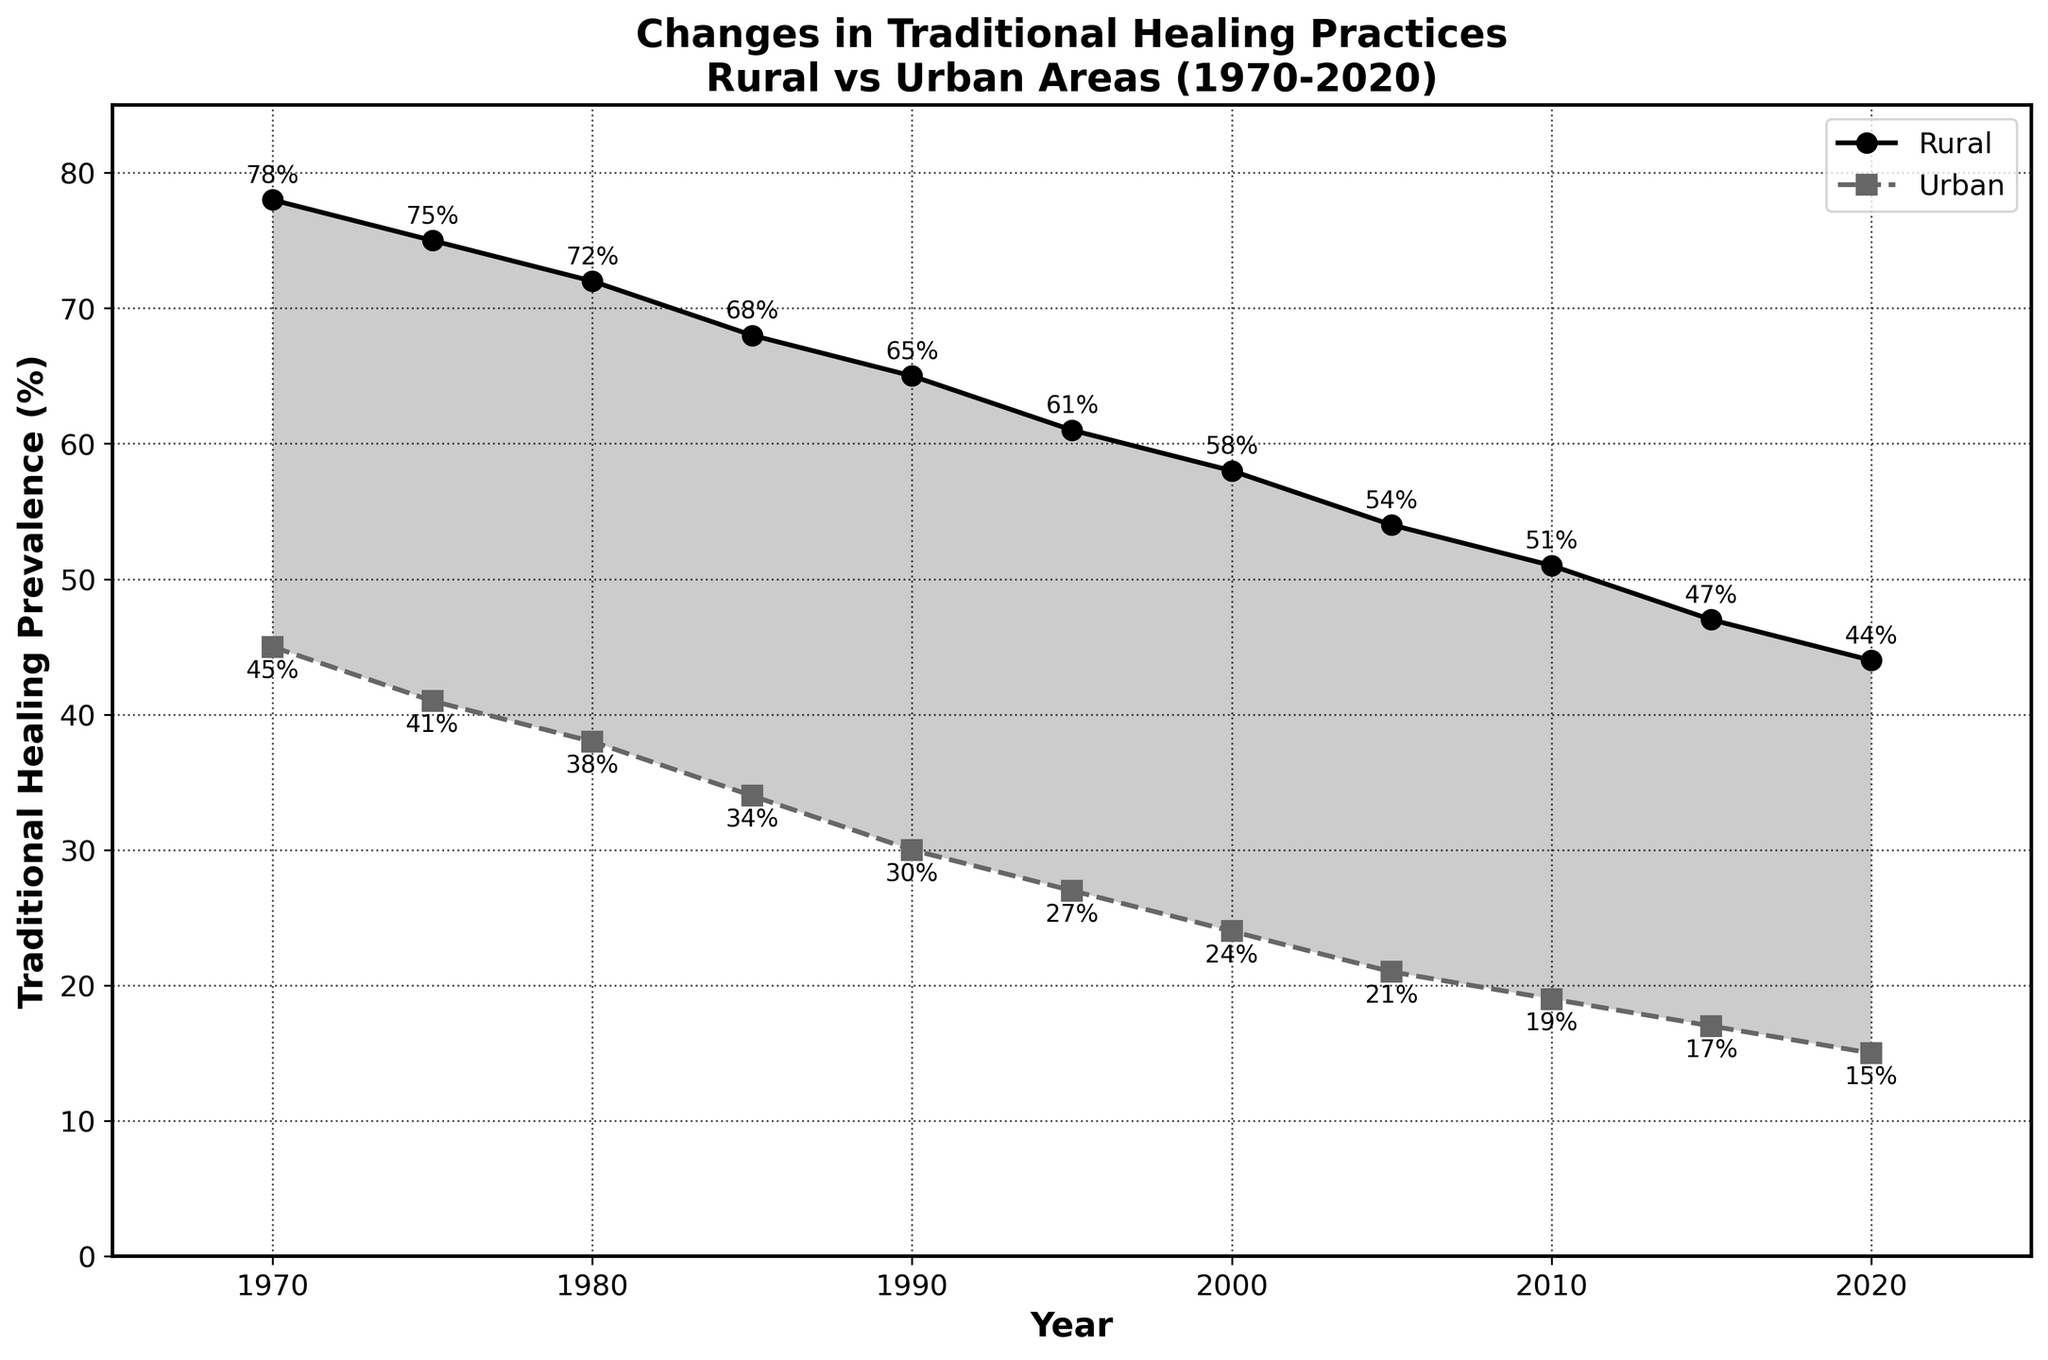What is the percentage difference in traditional healing practices between rural and urban areas in 1970? In 1970, rural traditional healing was at 78% and urban traditional healing was at 45%. The percentage difference is 78% - 45% = 33%.
Answer: 33% How many times has the prevalence of urban traditional healing decreased by 2% or more within a 5-year interval? By comparing the data, we can see that urban traditional healing decreased by 4% from 1970 to 1975, 3% from 1975 to 1980, 4% from 1980 to 1985, 4% from 1985 to 1990, 3% from 1990 to 1995, 3% from 1995 to 2000, 3% from 2000 to 2005, 2% from 2005 to 2010, and 2% from 2015 to 2020. That's 9 times in total.
Answer: 9 In which year was the gap between rural and urban traditional healing practices the smallest, and what was the size of this gap? The gaps for each year are as follows: 1970 (33%), 1975 (34%), 1980 (34%), 1985 (34%), 1990 (35%), 1995 (34%), 2000 (34%), 2005 (33%), 2010 (32%), 2015 (30%), 2020 (29%). The smallest gap occurred in 2020 and was 29%.
Answer: 2020, 29% What is the average annual decrease in the prevalence of rural traditional healing practices between 1970 and 2020? The prevalence in 1970 was 78%, and in 2020 it was 44%. The total decrease over 50 years is 78% - 44% = 34%. The average annual decrease is 34% / 50 years = 0.68% per year.
Answer: 0.68% per year Which period saw the largest percentage decrease in urban traditional healing practices? By comparing consecutive periods, the percentage decreases are: 1970 to 1975 (4%), 1975 to 1980 (3%), 1980 to 1985 (4%), 1985 to 1990 (4%), 1990 to 1995 (3%), 1995 to 2000 (3%), 2000 to 2005 (3%), 2005 to 2010 (2%), 2010 to 2015 (2%), 2015 to 2020 (2%). The largest percentage decrease was 4%, occurring during 1970 to 1975, 1980 to 1985, and 1985 to 1990.
Answer: 1970 to 1975, 1980 to 1985, 1985 to 1990 How much has urban traditional healing decreased from 1970 to 2000? In 1970, urban traditional healing was at 45%. By 2000, it had decreased to 24%. The total decrease is 45% - 24% = 21%.
Answer: 21% By what percentage did rural traditional healing practices decrease from 1970 to 1985? In 1970, rural traditional healing was at 78%. By 1985, it had decreased to 68%. The decrease is 78% - 68% = 10%.
Answer: 10% Which area (rural or urban) saw a continuous decrease in traditional healing practices every 5 years from 1970 to 2020? Both rural and urban areas saw continuous decreases every 5 years, but rural started at 78% and ended at 44%, while urban started at 45% and ended at 15%.
Answer: Both How does the trend in rural traditional healing practices compare to urban traditional healing practices over 50 years? Both rural and urban traditional healing practices show a decreasing trend over 50 years. Rural practices decreased from 78% to 44%, while urban practices decreased from 45% to 15%. However, the decline in rural areas is more gradual compared to the steeper decline in urban areas.
Answer: Both decreased, rural more gradually Which year had the same absolute decrease from the previous year for both rural and urban traditional healing practices? By checking each interval, the years 1990-1995 and 2005-2010 both had an equal absolute decrease of 3% and 3%, respectively, for both rural and urban areas.
Answer: 1990-1995, 2005-2010 